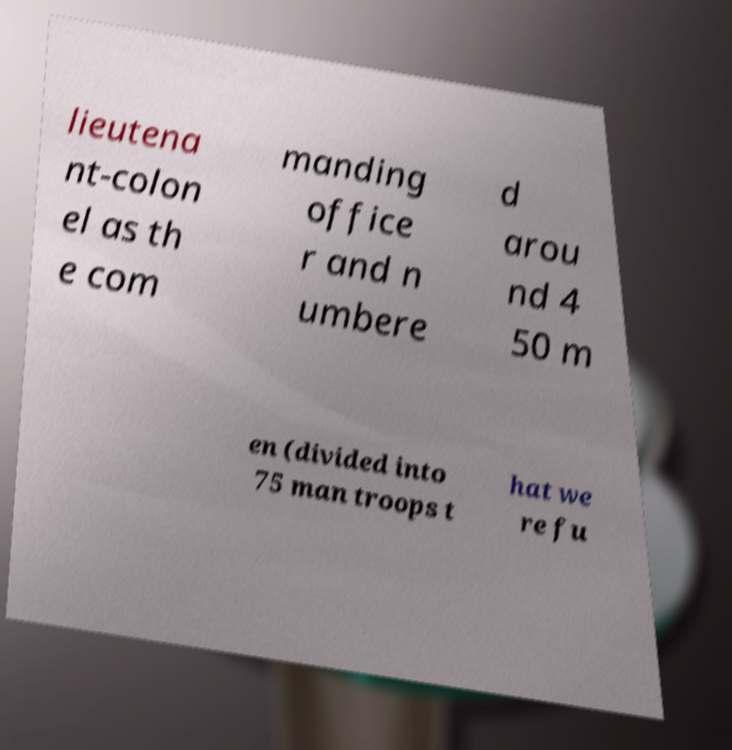Could you assist in decoding the text presented in this image and type it out clearly? lieutena nt-colon el as th e com manding office r and n umbere d arou nd 4 50 m en (divided into 75 man troops t hat we re fu 